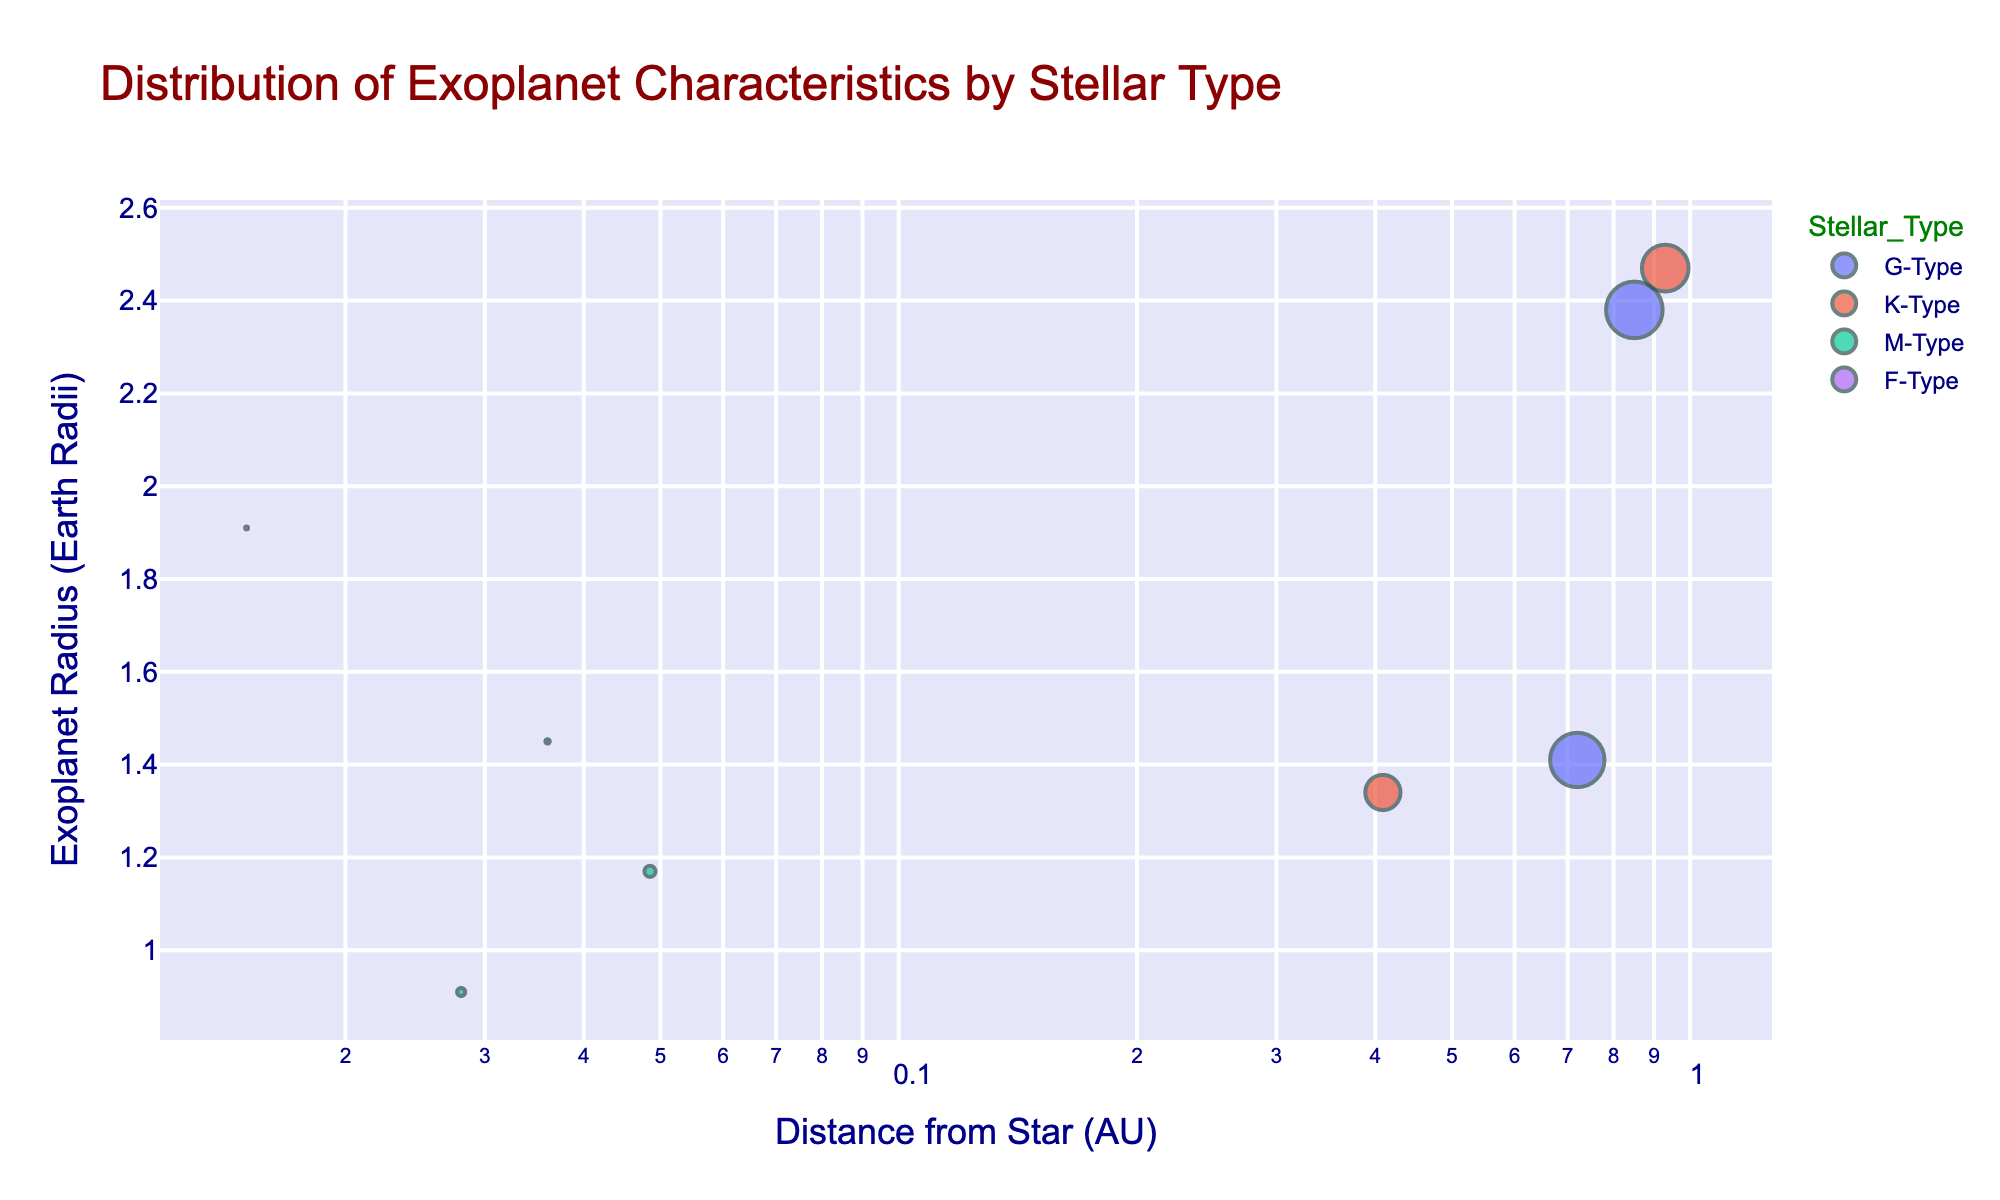What's the title of the plot? The title is usually displayed at the top of the plot. By reading this area, you can find the title that indicates what the plot is about.
Answer: Distribution of Exoplanet Characteristics by Stellar Type How many exoplanets orbit G-Type stars in the data? Look for the blue markers in the plot as they represent G-Type stars. Count the number of blue markers.
Answer: 2 Which exoplanet has the largest orbital period? Hover over the markers to reveal the names of exoplanets and observe their orbital periods. Compare these periods to find the largest one.
Answer: Kepler-22b What color represents M-Type stars in the plot? Examine the legend on the right side of the plot to see the color associated with M-Type stars.
Answer: Red Which stellar type has the exoplanet with the smallest distance from its star? Identify the exoplanet closest to the left side of the x-axis (Distance from Star) and check its color to determine the stellar type.
Answer: F-Type What is the total number of exoplanets in the plot? Count all the markers in the plot to determine the total number of exoplanets.
Answer: 8 What is the range of exoplanet radii (in Earth radii) for K-Type stars? Observe the markers corresponding to K-Type stars (green markers) and note their positions on the y-axis. Determine the minimum and maximum values.
Answer: 1.34 to 2.47 Earth radii How does the exoplanet radius generally change as the distance from the star increases? Follow the trend of the markers from left to right along the x-axis and observe the pattern on the y-axis to see whether the radius increases or decreases.
Answer: Generally increases Which exoplanet has the smallest radius and what is its stellar type? Find the marker with the lowest y-coordinate (Exoplanet Radius) and check its hover information for the exoplanet name and corresponding stellar type.
Answer: TRAPPIST-1e, M-Type Is there a trend in the orbital periods of exoplanets based on their distance from the star? Examine the marker sizes (representing orbital periods) along the x-axis (Distance from Star) to identify any patterns or trends.
Answer: No clear trend 